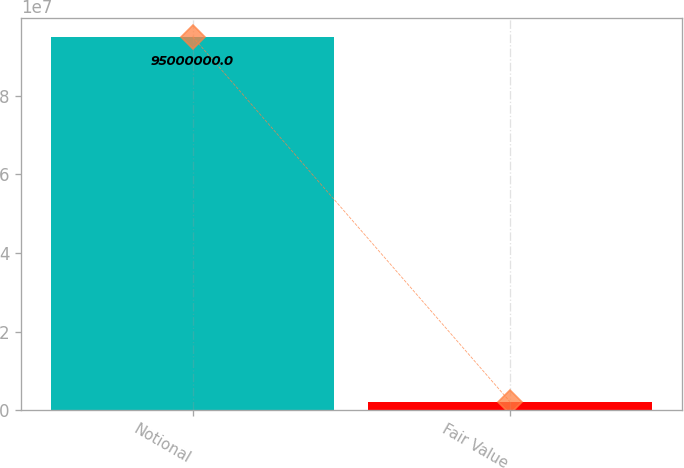<chart> <loc_0><loc_0><loc_500><loc_500><bar_chart><fcel>Notional<fcel>Fair Value<nl><fcel>9.5e+07<fcel>2.17937e+06<nl></chart> 